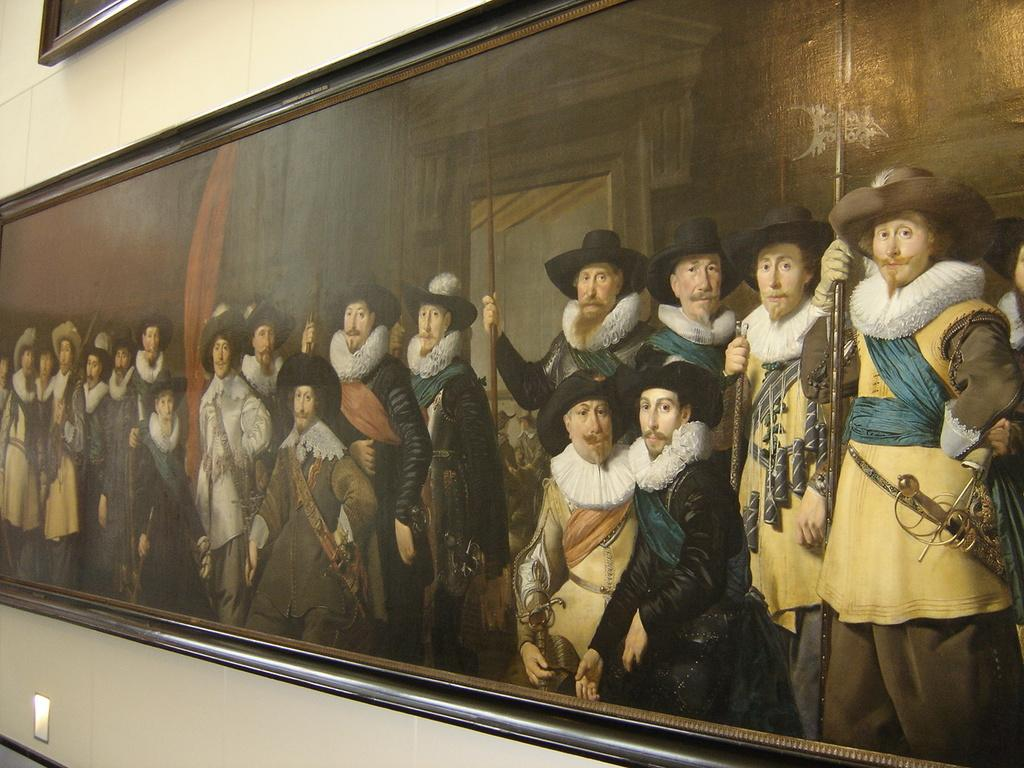What is the main subject in the image? There is a huge photo frame in the image. How is the photo frame positioned in the image? The photo frame is attached to the wall. What can be seen within the photo frame? There are multiple depictions within the photo frame. What type of record can be seen on the sidewalk near the photo frame? There is no record or sidewalk present in the image; it only features a huge photo frame attached to the wall with multiple depictions inside. 